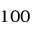Convert formula to latex. <formula><loc_0><loc_0><loc_500><loc_500>1 0 0</formula> 